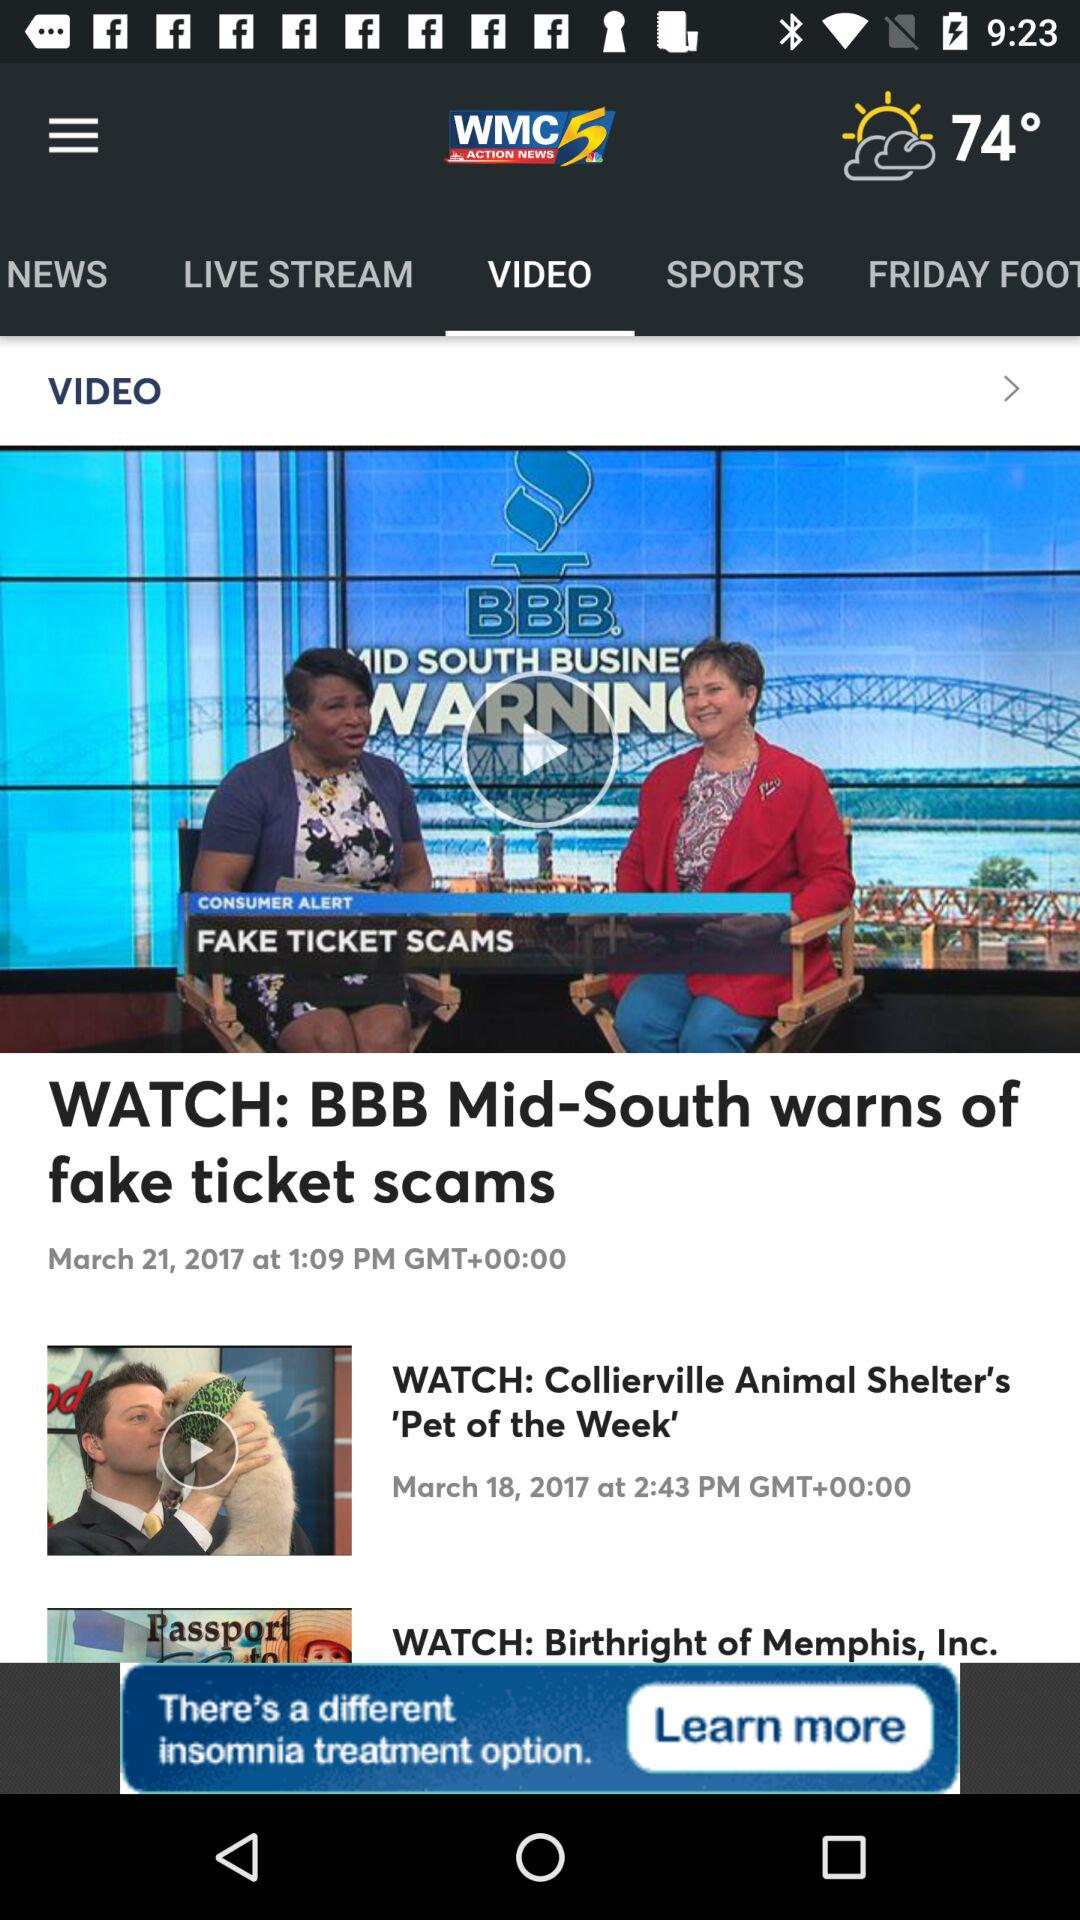What is the timing of bbb mid-south warns of fake ticket scams show?
When the provided information is insufficient, respond with <no answer>. <no answer> 